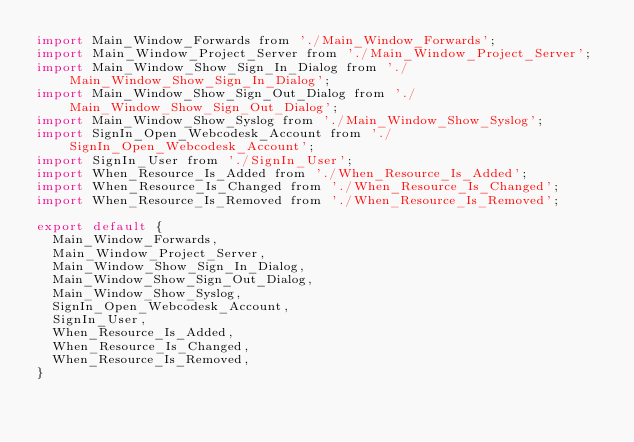Convert code to text. <code><loc_0><loc_0><loc_500><loc_500><_JavaScript_>import Main_Window_Forwards from './Main_Window_Forwards';
import Main_Window_Project_Server from './Main_Window_Project_Server';
import Main_Window_Show_Sign_In_Dialog from './Main_Window_Show_Sign_In_Dialog';
import Main_Window_Show_Sign_Out_Dialog from './Main_Window_Show_Sign_Out_Dialog';
import Main_Window_Show_Syslog from './Main_Window_Show_Syslog';
import SignIn_Open_Webcodesk_Account from './SignIn_Open_Webcodesk_Account';
import SignIn_User from './SignIn_User';
import When_Resource_Is_Added from './When_Resource_Is_Added';
import When_Resource_Is_Changed from './When_Resource_Is_Changed';
import When_Resource_Is_Removed from './When_Resource_Is_Removed';

export default {
  Main_Window_Forwards,
  Main_Window_Project_Server,
  Main_Window_Show_Sign_In_Dialog,
  Main_Window_Show_Sign_Out_Dialog,
  Main_Window_Show_Syslog,
  SignIn_Open_Webcodesk_Account,
  SignIn_User,
  When_Resource_Is_Added,
  When_Resource_Is_Changed,
  When_Resource_Is_Removed,
}
</code> 